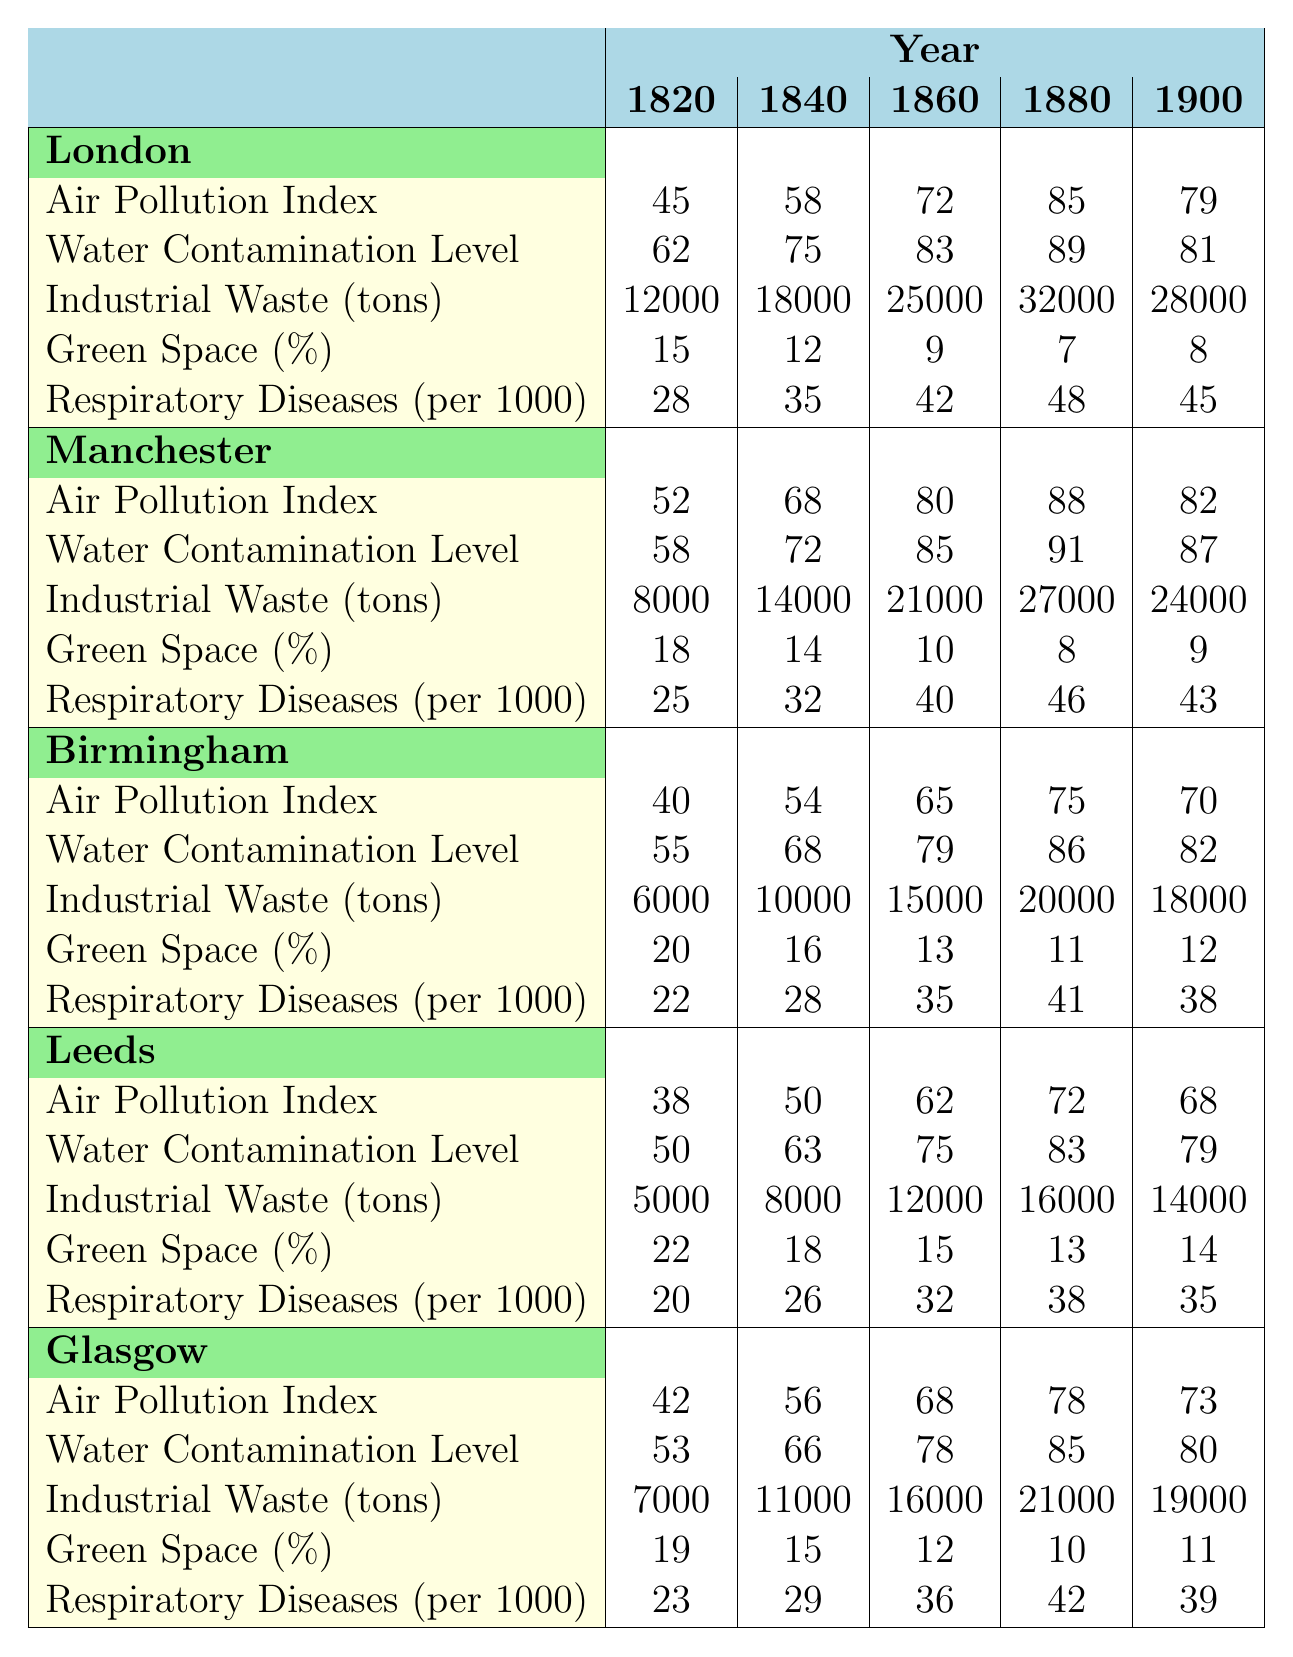What was the air pollution index for London in 1880? The table shows that the air pollution index for London in 1880 is 85.
Answer: 85 Which city had the highest water contamination level in 1860? In 1860, the water contamination levels were 83 for London, 85 for Manchester, 79 for Birmingham, 75 for Leeds, and 78 for Glasgow. Therefore, the highest level was in Manchester with a level of 85.
Answer: Manchester What was the percentage of green space in Birmingham in 1840? The table indicates that Birmingham had a green space percentage of 16 in 1840.
Answer: 16 How many tons of industrial waste were produced in Leeds in 1900? The industrial waste tons produced in Leeds in 1900, according to the table, were 14,000 tons.
Answer: 14,000 Did the air pollution index in Glasgow decrease from 1860 to 1900? In 1860, Glasgow's air pollution index was 68, and in 1900 it was 73, indicating it did not decrease but increased instead.
Answer: No What was the change in industrial waste in Manchester from 1820 to 1900? In 1820, Manchester produced 8,000 tons of industrial waste and in 1900 it produced 24,000 tons. The change is 24,000 - 8,000 = 16,000 tons.
Answer: 16,000 tons Which city's respiratory diseases per 1000 showed the highest value in 1880? In 1880, London had 48, Manchester had 46, Birmingham had 41, Leeds had 38, and Glasgow had 42 respiratory diseases per 1000. Hence, London had the highest value.
Answer: London What was the average air pollution index across all cities in 1860? The air pollution indices in 1860 were: London (72), Manchester (80), Birmingham (65), Leeds (62), and Glasgow (68). The average is calculated as (72 + 80 + 65 + 62 + 68) / 5 = 67.4.
Answer: 67.4 Which city had the lowest green space percentage in 1900? In 1900, the green space percentages were: London (8), Manchester (9), Birmingham (12), Leeds (14), and Glasgow (11). Hence, London had the lowest percentage.
Answer: London Was there a consistent increase in industrial waste in Birmingham from 1820 to 1880? In Birmingham, the industrial waste increased from 6,000 tons in 1820 to 10,000 tons in 1840, then to 15,000 tons in 1860, and reached 20,000 tons in 1880. Thus, it shows a consistent increase over these years.
Answer: Yes 